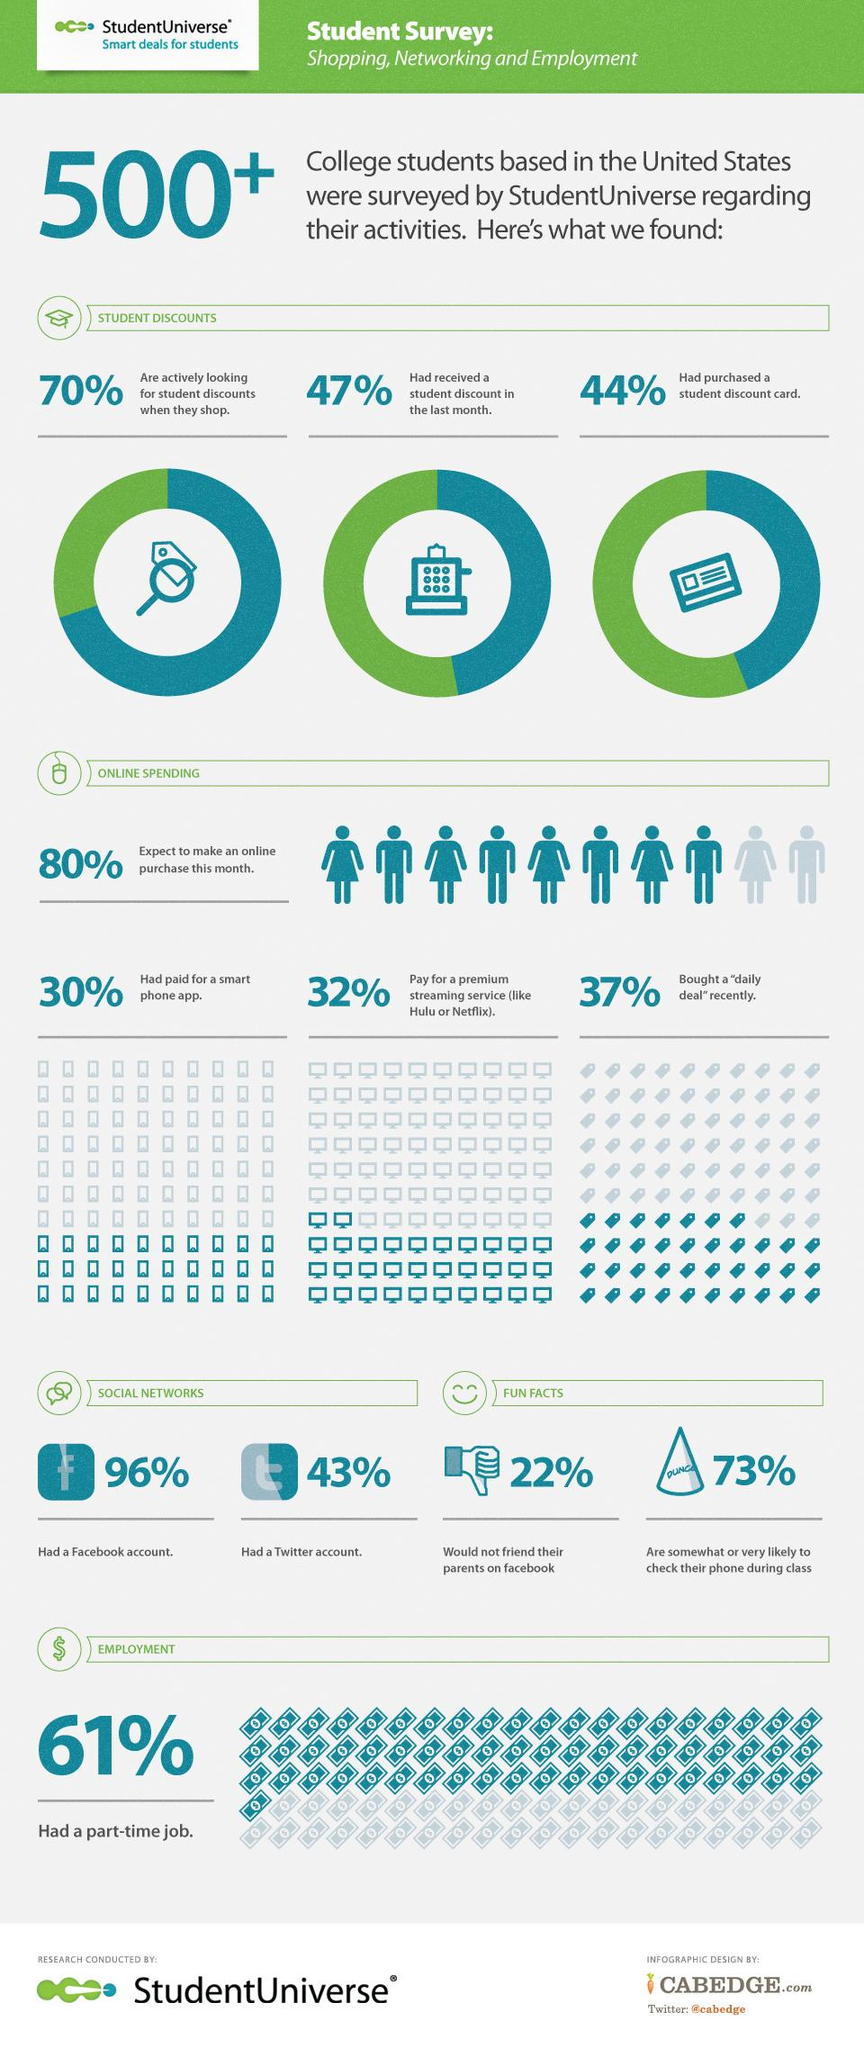Indicate a few pertinent items in this graphic. A recent study found that a significant portion of students, approximately 63%, did not purchase a daily deal. According to a recent survey, approximately 30% of students do not look for a student discount card when they shop. It is expected that a significant percentage of students will not make a purchase in the current month. A significant percentage of students do not have a Facebook account. According to a recent survey, 43% of students already have a Twitter account. 